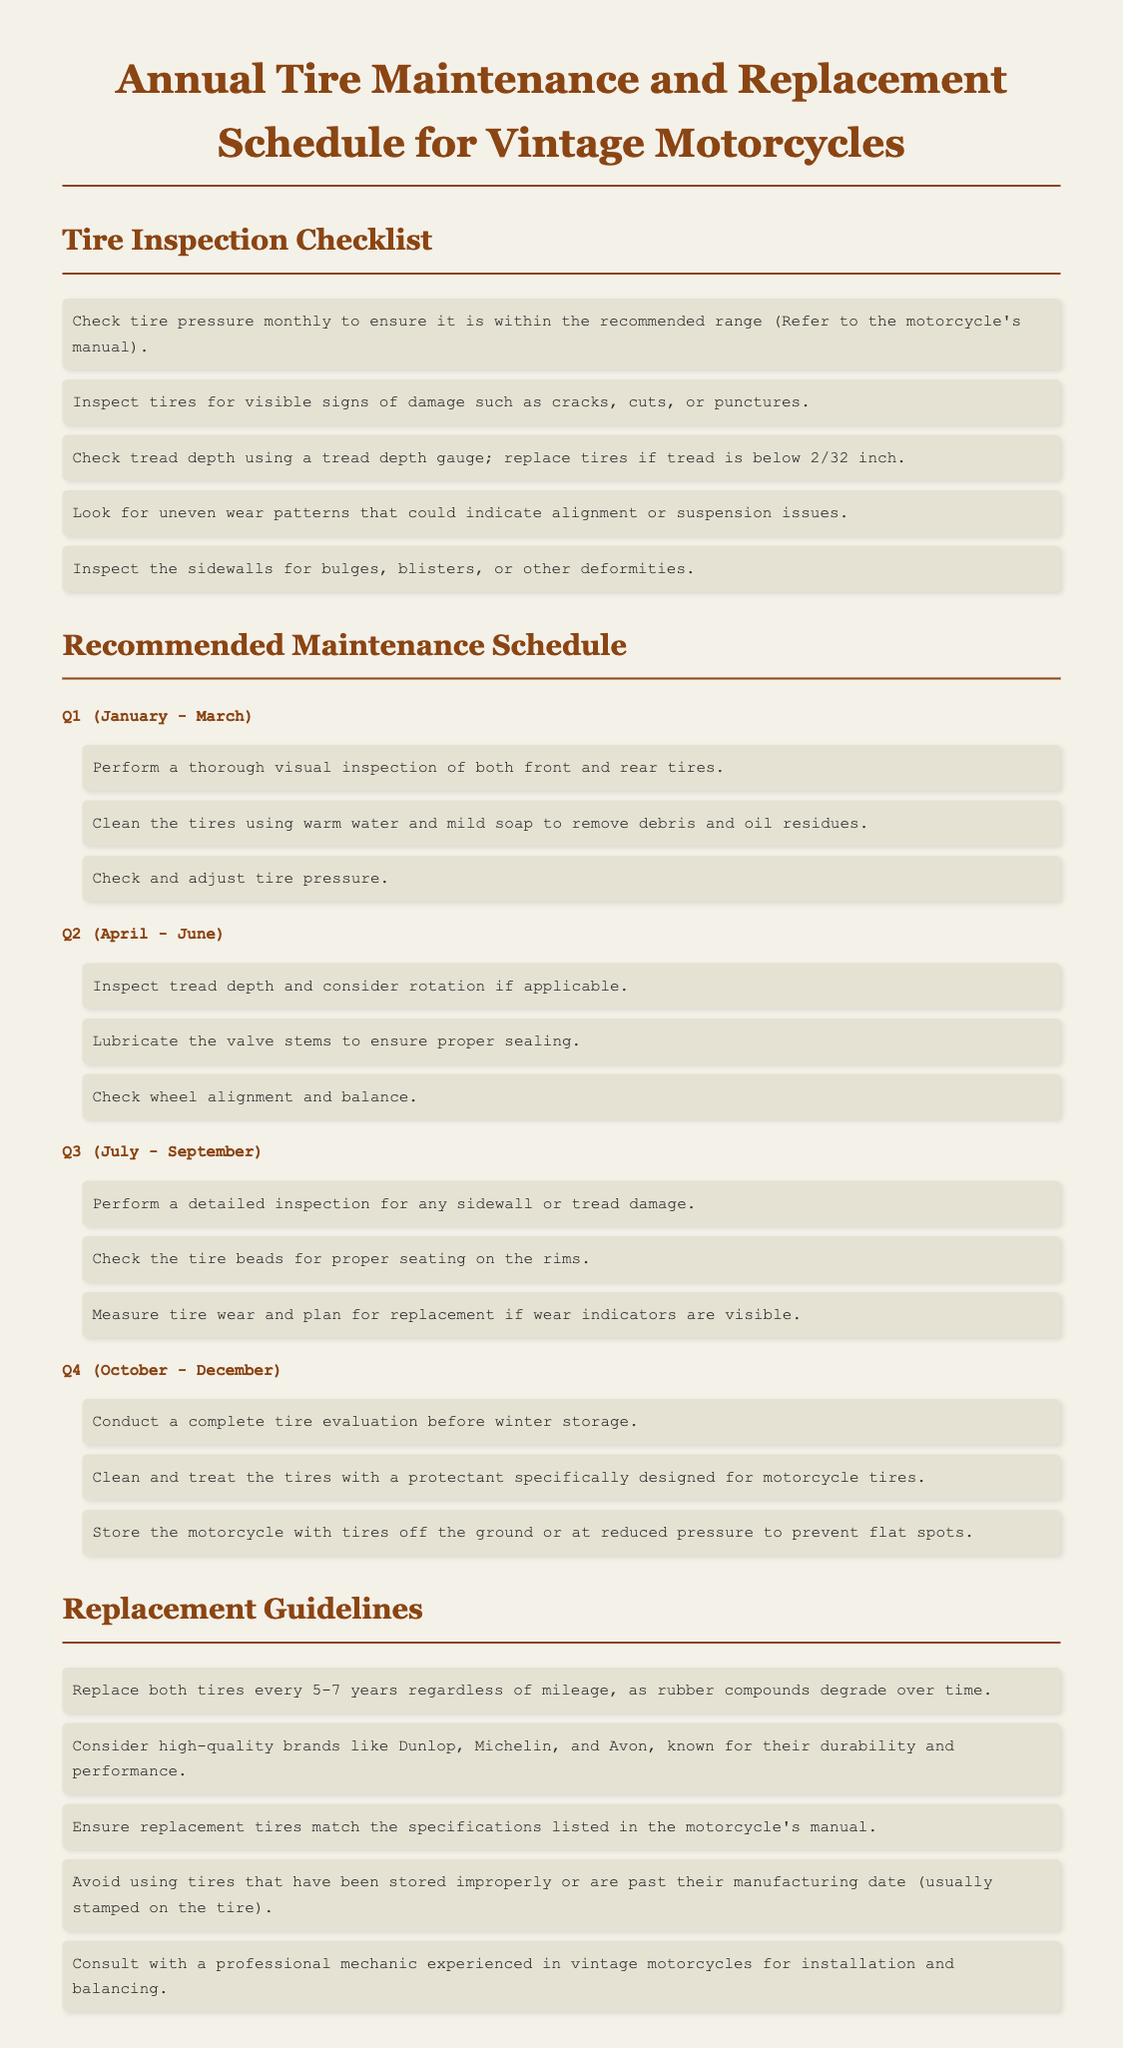What is the maximum tread depth before replacement is necessary? The document states that tires should be replaced if tread depth is below 2/32 inch.
Answer: 2/32 inch What is the recommended tire cleaning solution? The schedule advises cleaning tires using warm water and mild soap.
Answer: Warm water and mild soap How often should tire pressure be checked? The maintenance log indicates tire pressure should be checked monthly.
Answer: Monthly What is the replacement interval for tires regardless of mileage? The document recommends replacing tires every 5-7 years.
Answer: 5-7 years Which quarter involves cleaning and treating the tires? The complete tire evaluation and treatment is scheduled for Q4 (October - December).
Answer: Q4 What is a preferred brand for replacement tires? The log suggests considering high-quality brands like Dunlop.
Answer: Dunlop What type of inspection is recommended in Q1? A thorough visual inspection of both front and rear tires is advised in Q1.
Answer: Thorough visual inspection What should be checked in Q2 along with tread depth? In Q2, wheel alignment and balance should also be checked.
Answer: Wheel alignment and balance Which aspect of the tire is evaluated in Q3? Q3 focuses on inspecting for sidewall or tread damage.
Answer: Sidewall or tread damage 